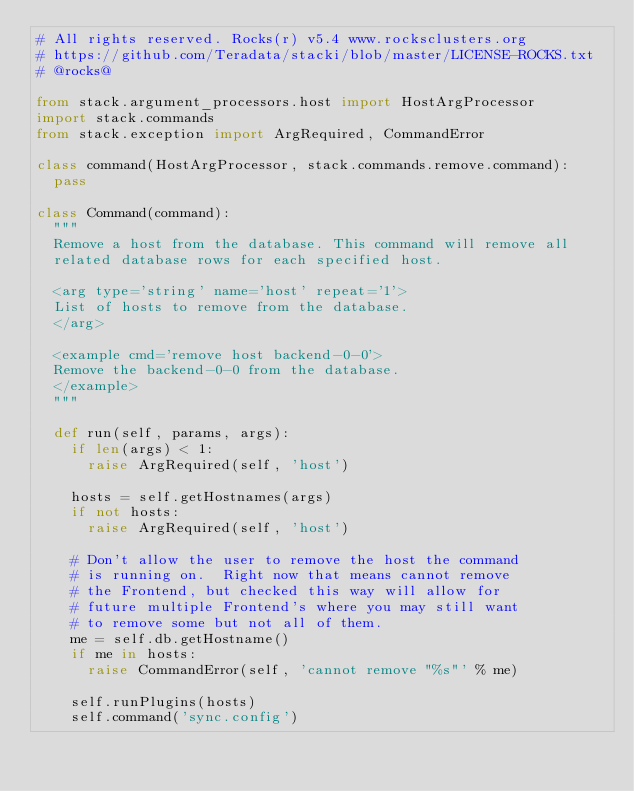<code> <loc_0><loc_0><loc_500><loc_500><_Python_># All rights reserved. Rocks(r) v5.4 www.rocksclusters.org
# https://github.com/Teradata/stacki/blob/master/LICENSE-ROCKS.txt
# @rocks@

from stack.argument_processors.host import HostArgProcessor
import stack.commands
from stack.exception import ArgRequired, CommandError

class command(HostArgProcessor, stack.commands.remove.command):
	pass

class Command(command):
	"""
	Remove a host from the database. This command will remove all
	related database rows for each specified host.

	<arg type='string' name='host' repeat='1'>
	List of hosts to remove from the database.
	</arg>

	<example cmd='remove host backend-0-0'>
	Remove the backend-0-0 from the database.
	</example>
	"""

	def run(self, params, args):
		if len(args) < 1:
			raise ArgRequired(self, 'host')

		hosts = self.getHostnames(args)
		if not hosts:
			raise ArgRequired(self, 'host')

		# Don't allow the user to remove the host the command
		# is running on.  Right now that means cannot remove
		# the Frontend, but checked this way will allow for
		# future multiple Frontend's where you may still want
		# to remove some but not all of them.
		me = self.db.getHostname()
		if me in hosts:
			raise CommandError(self, 'cannot remove "%s"' % me)

		self.runPlugins(hosts)
		self.command('sync.config')
</code> 